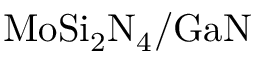<formula> <loc_0><loc_0><loc_500><loc_500>M o S i _ { 2 } N _ { 4 } / G a N</formula> 